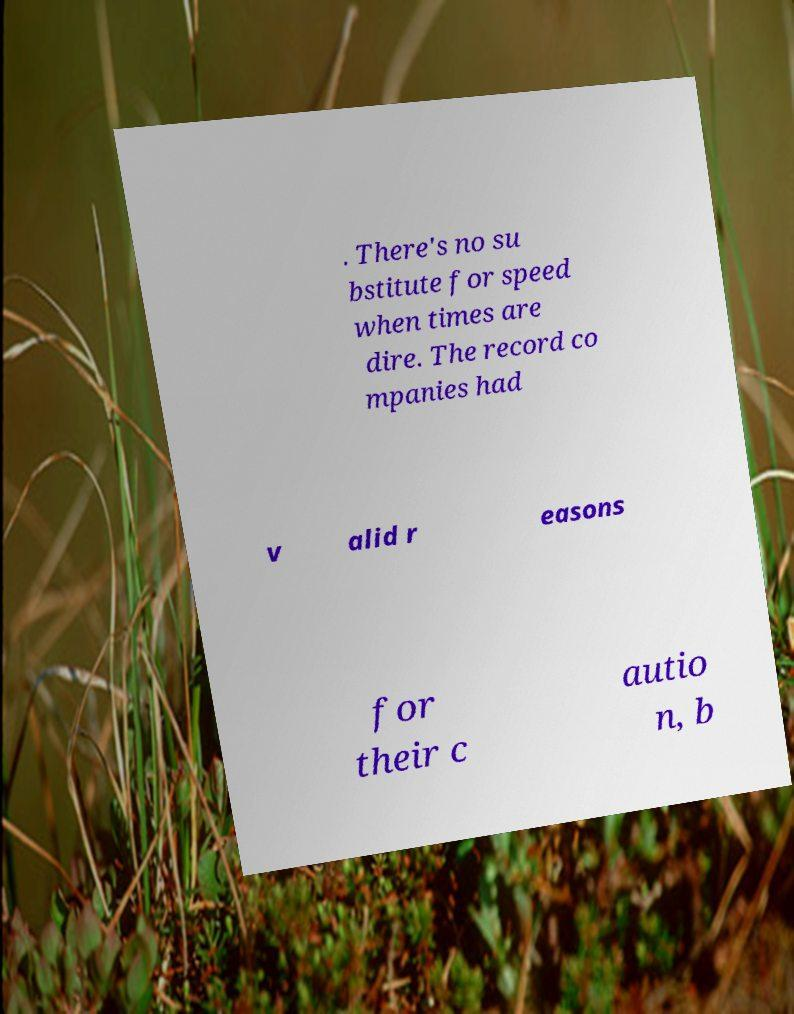There's text embedded in this image that I need extracted. Can you transcribe it verbatim? . There's no su bstitute for speed when times are dire. The record co mpanies had v alid r easons for their c autio n, b 